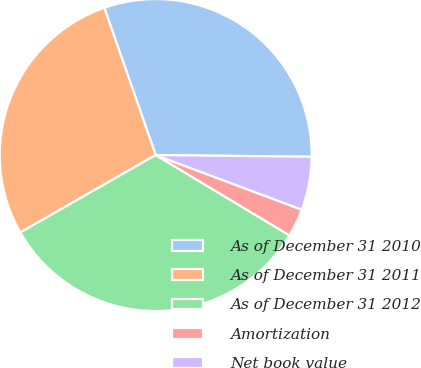Convert chart to OTSL. <chart><loc_0><loc_0><loc_500><loc_500><pie_chart><fcel>As of December 31 2010<fcel>As of December 31 2011<fcel>As of December 31 2012<fcel>Amortization<fcel>Net book value<nl><fcel>30.52%<fcel>27.92%<fcel>33.12%<fcel>2.91%<fcel>5.51%<nl></chart> 